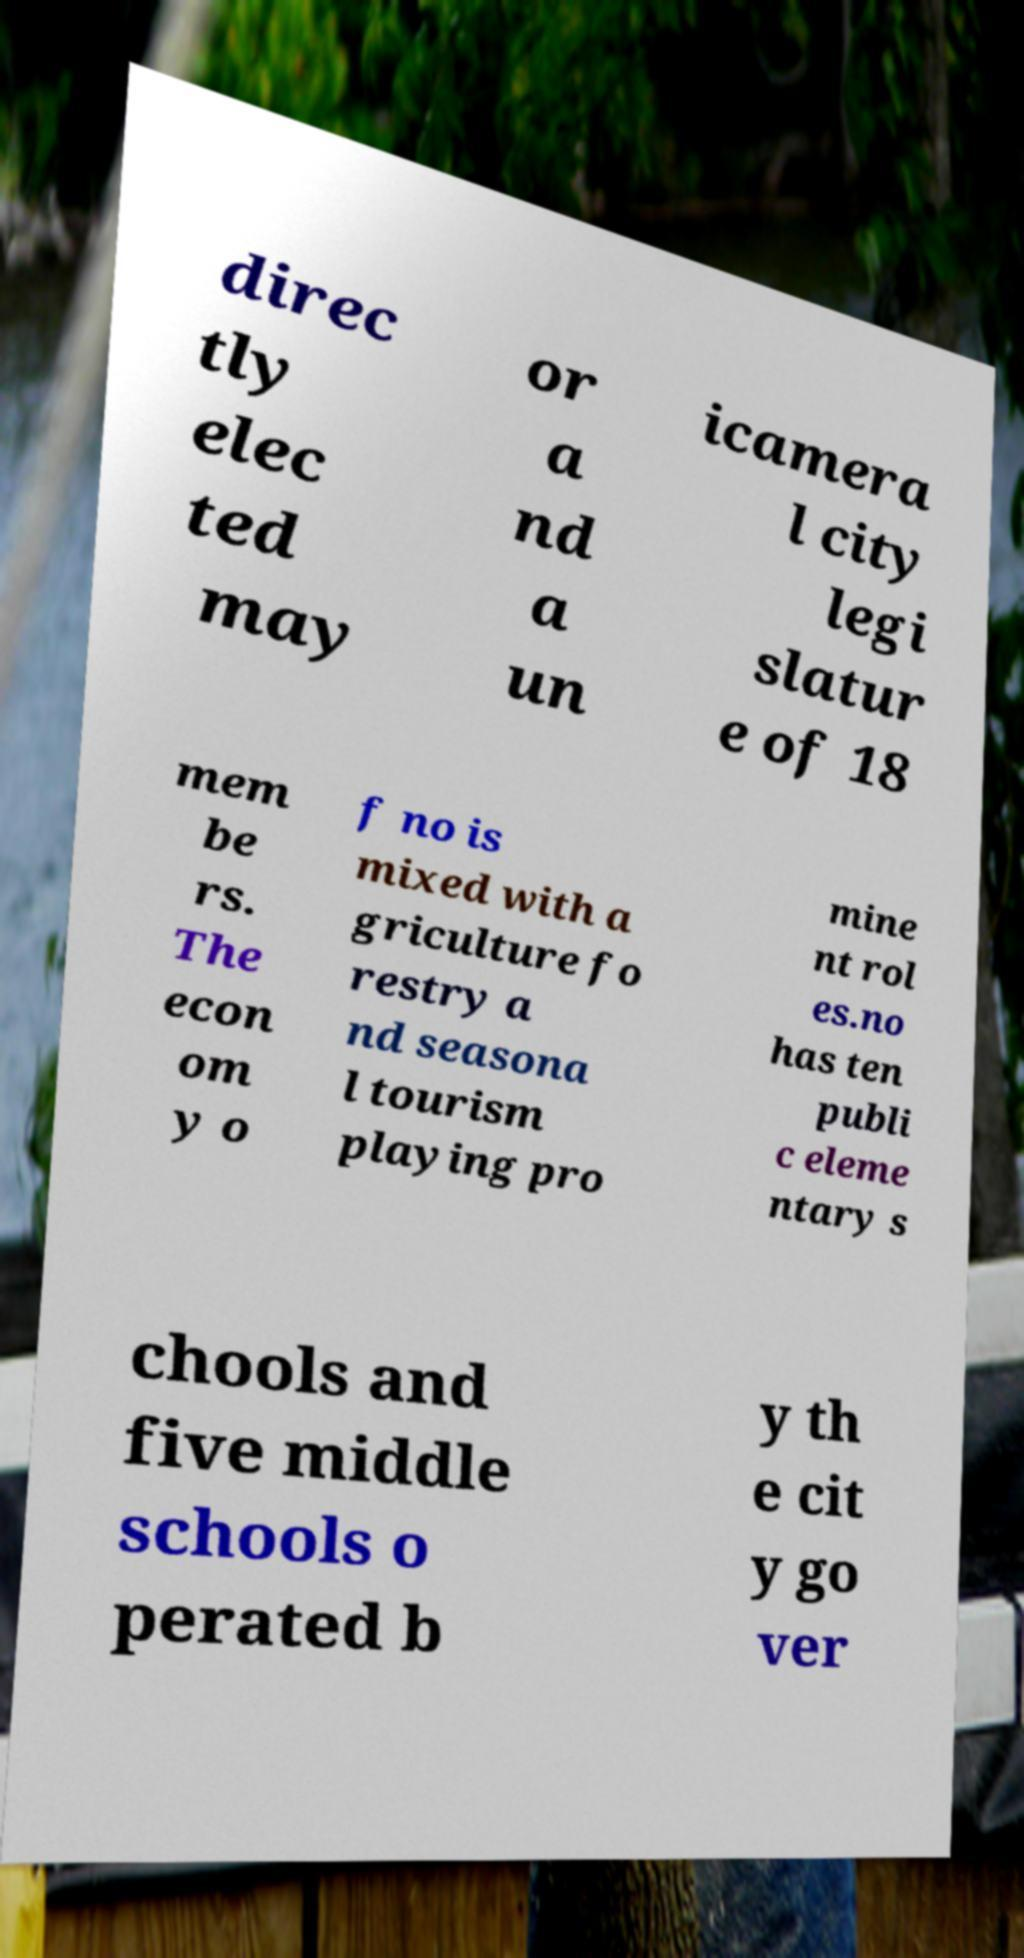Could you assist in decoding the text presented in this image and type it out clearly? direc tly elec ted may or a nd a un icamera l city legi slatur e of 18 mem be rs. The econ om y o f no is mixed with a griculture fo restry a nd seasona l tourism playing pro mine nt rol es.no has ten publi c eleme ntary s chools and five middle schools o perated b y th e cit y go ver 